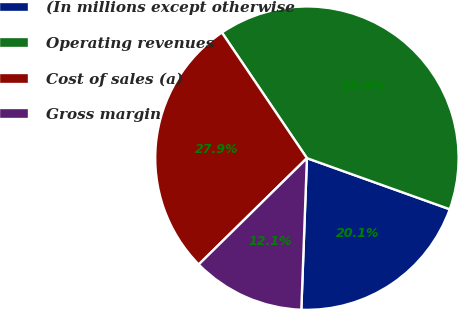Convert chart. <chart><loc_0><loc_0><loc_500><loc_500><pie_chart><fcel>(In millions except otherwise<fcel>Operating revenues<fcel>Cost of sales (a)<fcel>Gross margin<nl><fcel>20.12%<fcel>39.94%<fcel>27.89%<fcel>12.05%<nl></chart> 